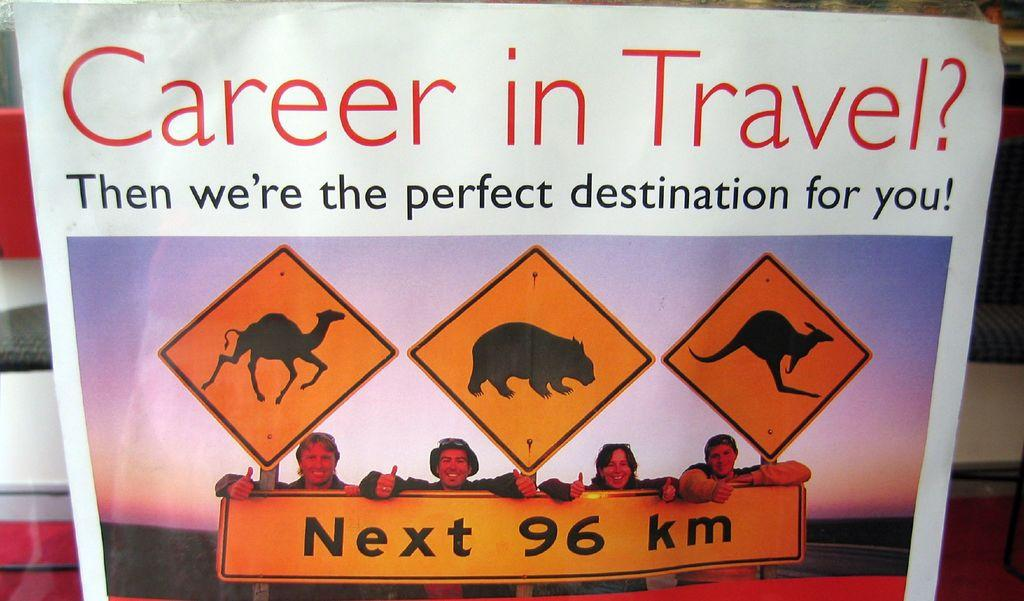<image>
Offer a succinct explanation of the picture presented. A poster promotes opportunities for careers in travel. 